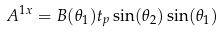<formula> <loc_0><loc_0><loc_500><loc_500>A ^ { 1 x } = B ( \theta _ { 1 } ) t _ { p } \sin ( \theta _ { 2 } ) \sin ( \theta _ { 1 } )</formula> 